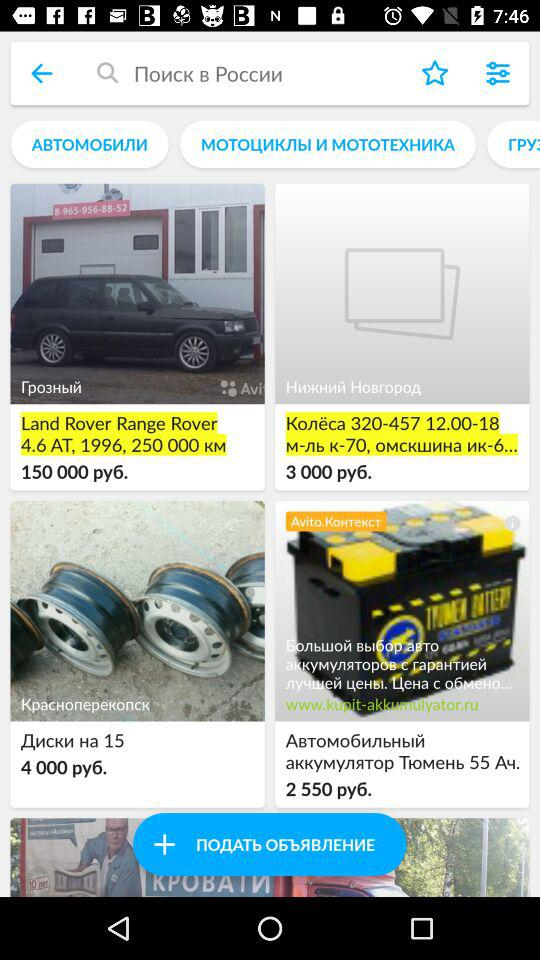What is the difference between the price of the first and second item?
Answer the question using a single word or phrase. 147000 